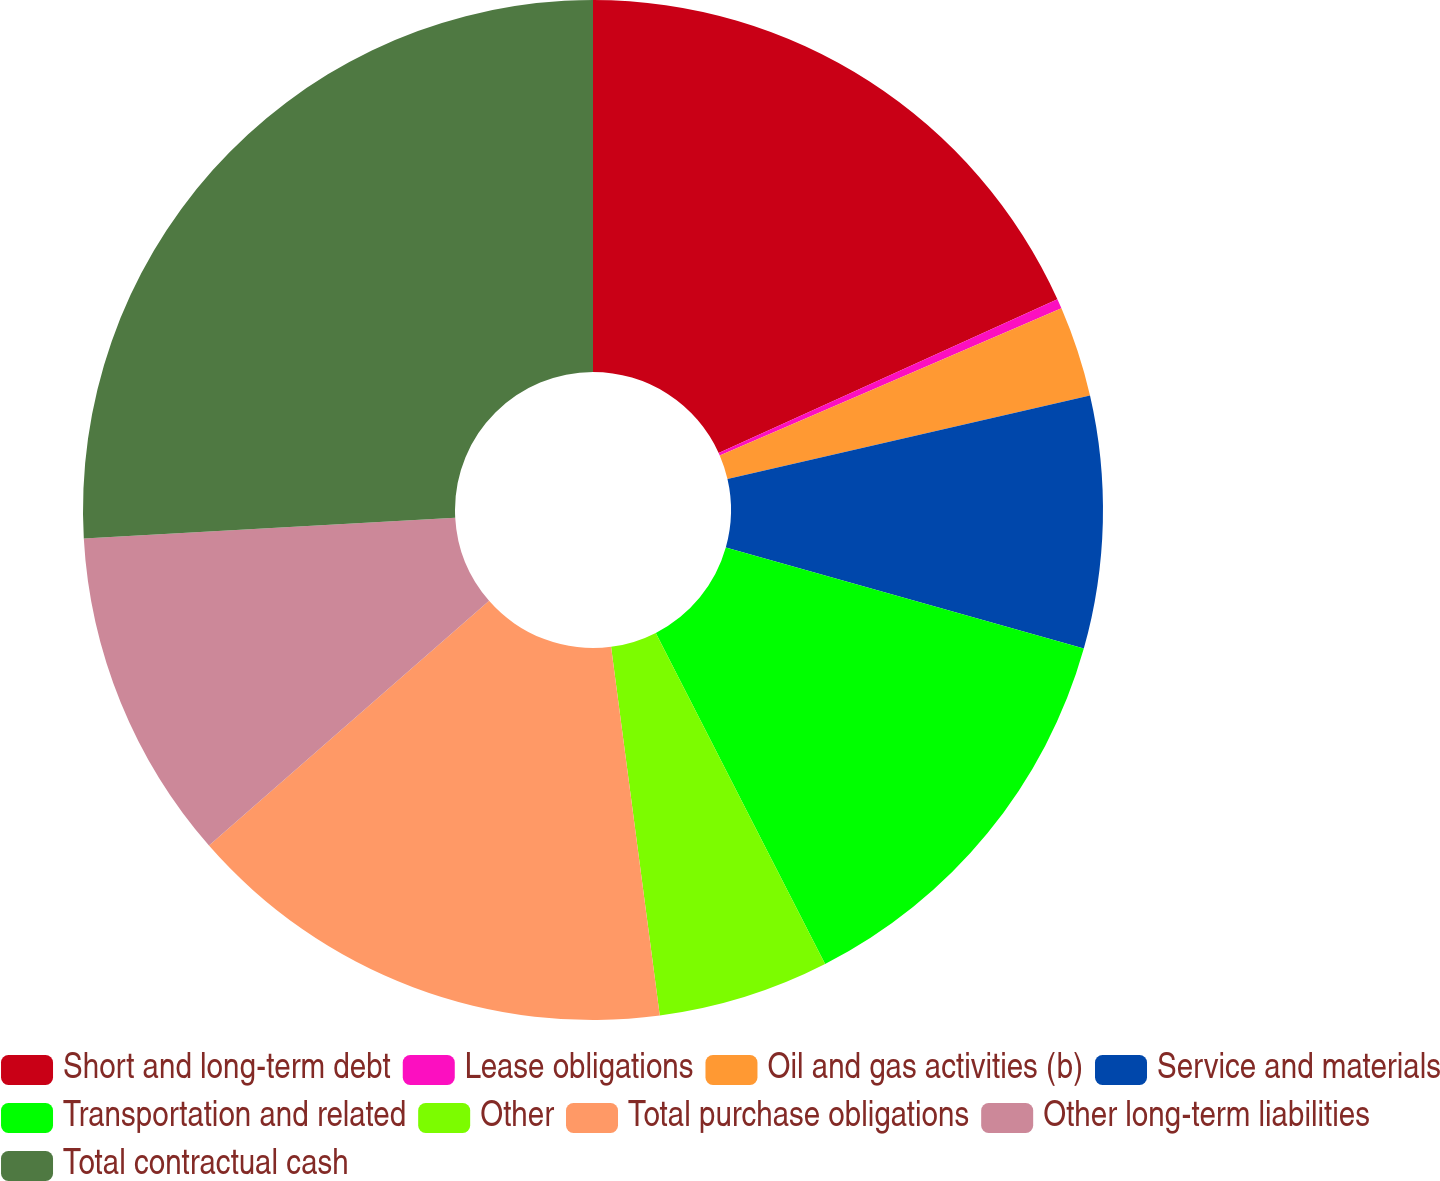Convert chart. <chart><loc_0><loc_0><loc_500><loc_500><pie_chart><fcel>Short and long-term debt<fcel>Lease obligations<fcel>Oil and gas activities (b)<fcel>Service and materials<fcel>Transportation and related<fcel>Other<fcel>Total purchase obligations<fcel>Other long-term liabilities<fcel>Total contractual cash<nl><fcel>18.22%<fcel>0.31%<fcel>2.87%<fcel>7.98%<fcel>13.1%<fcel>5.43%<fcel>15.66%<fcel>10.54%<fcel>25.89%<nl></chart> 